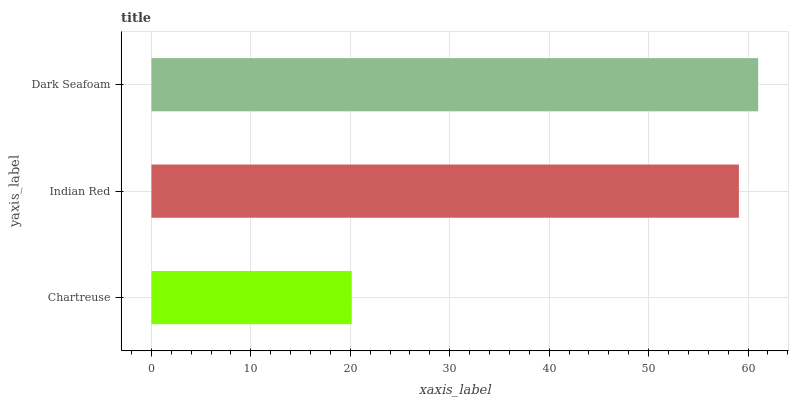Is Chartreuse the minimum?
Answer yes or no. Yes. Is Dark Seafoam the maximum?
Answer yes or no. Yes. Is Indian Red the minimum?
Answer yes or no. No. Is Indian Red the maximum?
Answer yes or no. No. Is Indian Red greater than Chartreuse?
Answer yes or no. Yes. Is Chartreuse less than Indian Red?
Answer yes or no. Yes. Is Chartreuse greater than Indian Red?
Answer yes or no. No. Is Indian Red less than Chartreuse?
Answer yes or no. No. Is Indian Red the high median?
Answer yes or no. Yes. Is Indian Red the low median?
Answer yes or no. Yes. Is Dark Seafoam the high median?
Answer yes or no. No. Is Dark Seafoam the low median?
Answer yes or no. No. 